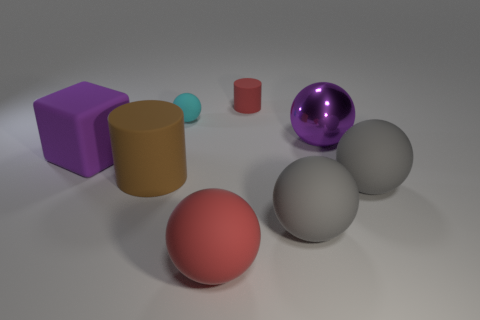What material is the object that is the same color as the big metallic ball?
Provide a succinct answer. Rubber. There is a metallic ball that is to the right of the big purple cube; is it the same color as the rubber block?
Your answer should be very brief. Yes. How many other objects are there of the same color as the small rubber sphere?
Your response must be concise. 0. Is the material of the big purple object behind the large cube the same as the tiny cylinder?
Ensure brevity in your answer.  No. There is a tiny object that is to the left of the big red sphere; what is it made of?
Your answer should be compact. Rubber. There is a cylinder that is left of the red object that is in front of the tiny cyan matte ball; how big is it?
Keep it short and to the point. Large. Are there any spheres that have the same material as the big block?
Provide a succinct answer. Yes. There is a large purple object left of the big matte sphere that is to the left of the red thing behind the tiny cyan sphere; what is its shape?
Offer a terse response. Cube. There is a big matte cube in front of the small red rubber cylinder; does it have the same color as the big ball that is behind the big rubber cylinder?
Offer a terse response. Yes. Are there any small spheres behind the rubber cube?
Provide a short and direct response. Yes. 